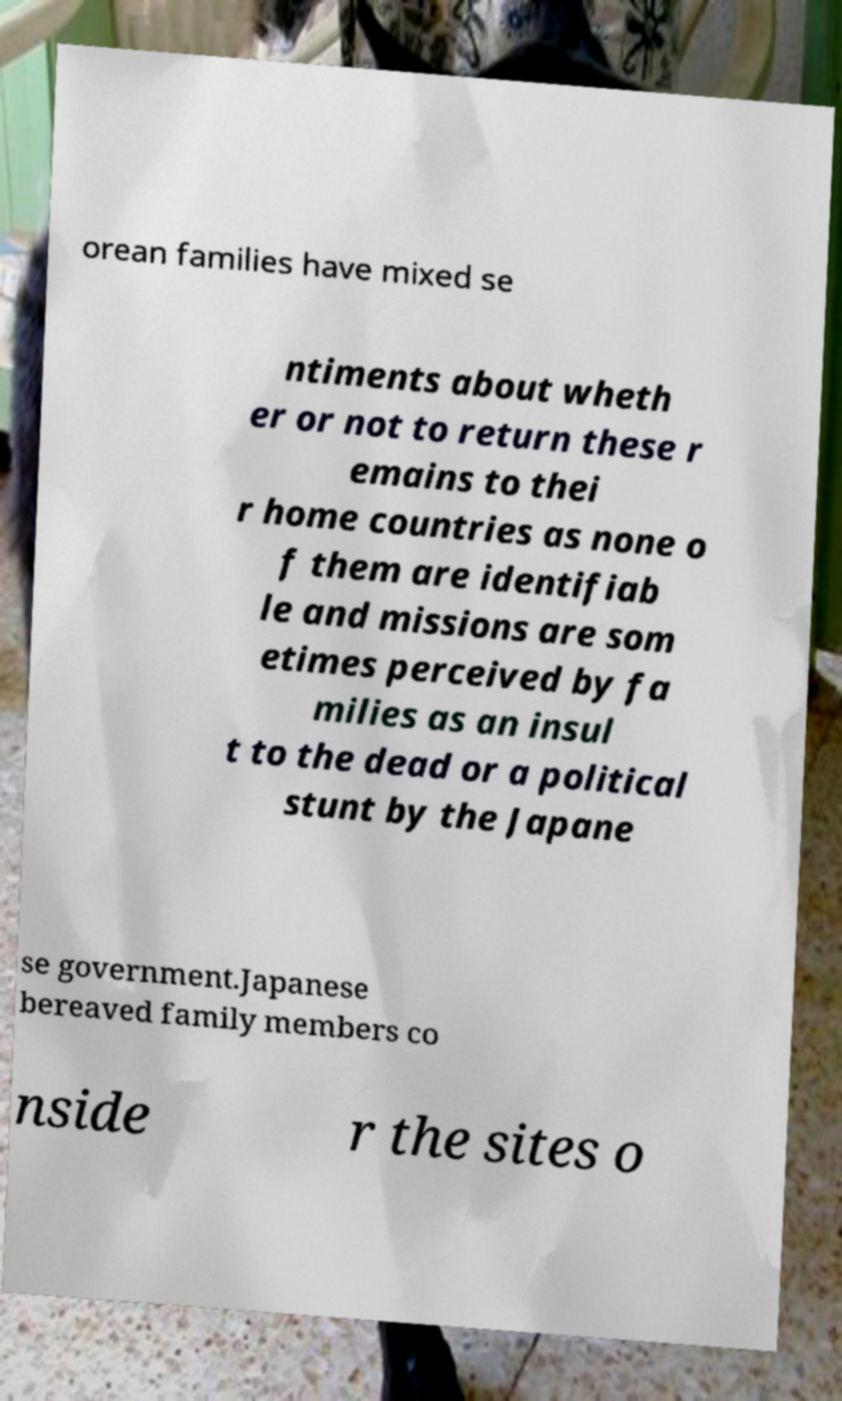Could you assist in decoding the text presented in this image and type it out clearly? orean families have mixed se ntiments about wheth er or not to return these r emains to thei r home countries as none o f them are identifiab le and missions are som etimes perceived by fa milies as an insul t to the dead or a political stunt by the Japane se government.Japanese bereaved family members co nside r the sites o 